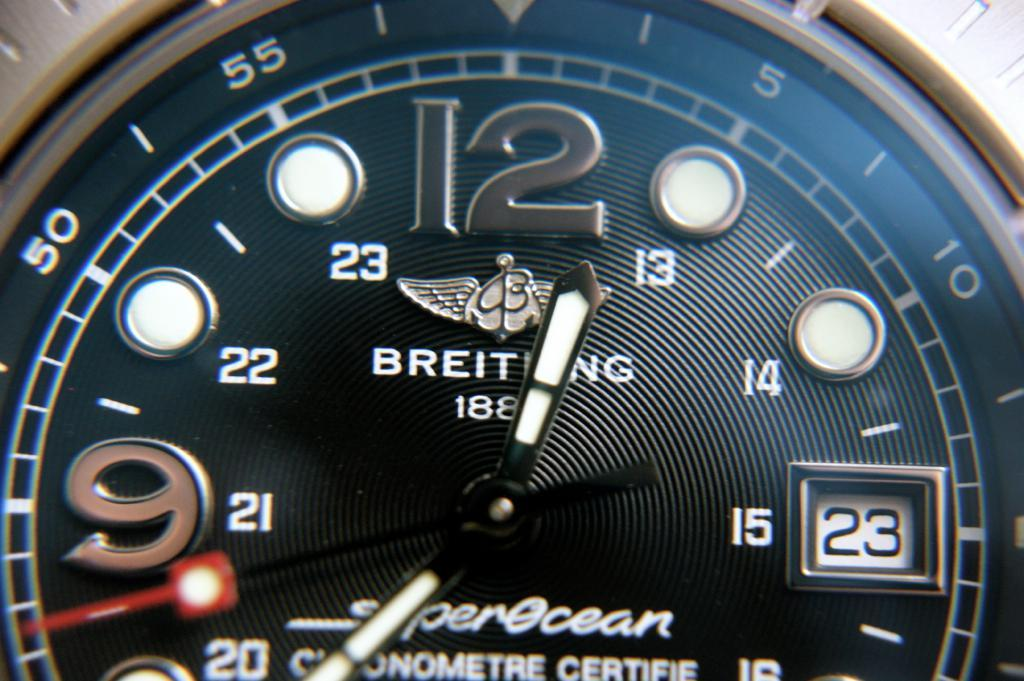<image>
Relay a brief, clear account of the picture shown. A close up of a partial watch face shows the large numbers 12 and 9, the words SuperOcian Chronometre Certifif and the partial word BREIT..NG 